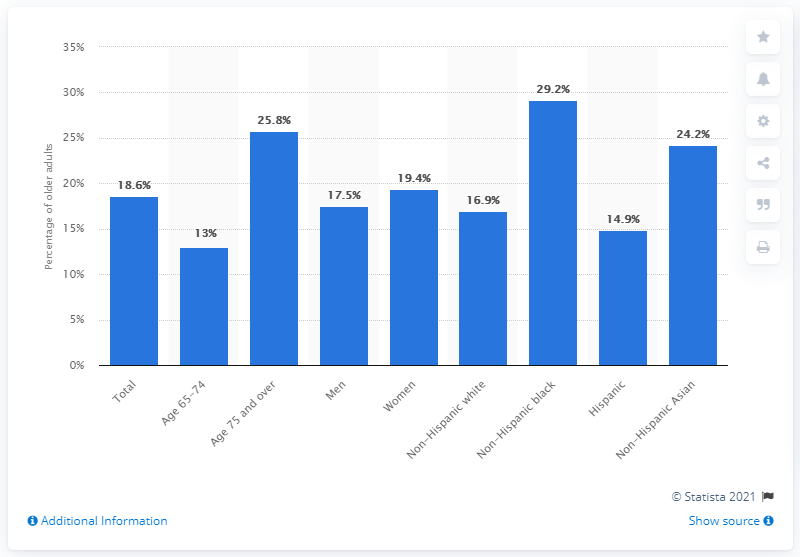Identify some key points in this picture. In 2011-2012, it was found that 29.2% of older non-Hispanic black adults had complete tooth loss. 